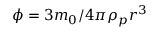Convert formula to latex. <formula><loc_0><loc_0><loc_500><loc_500>\phi = 3 m _ { 0 } / 4 \pi \rho _ { p } r ^ { 3 }</formula> 